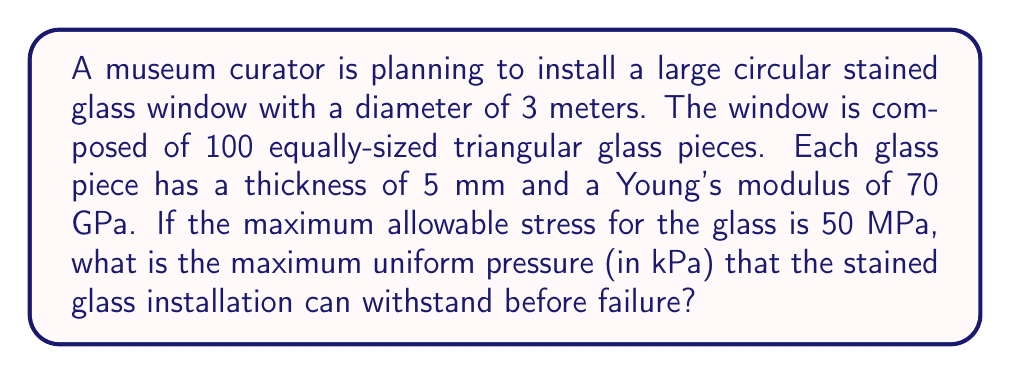Give your solution to this math problem. To solve this problem, we need to use stress analysis and the concept of structural integrity. Let's break it down step by step:

1. Calculate the area of the circular window:
   $$A = \pi r^2 = \pi (1.5\text{ m})^2 = 7.0686\text{ m}^2$$

2. Calculate the area of each triangular glass piece:
   $$A_{\text{piece}} = \frac{A}{100} = 0.070686\text{ m}^2$$

3. Assume each triangular piece is equilateral. Calculate the side length:
   $$s = \sqrt{\frac{4A_{\text{piece}}}{\sqrt{3}}} = 0.3162\text{ m}$$

4. Calculate the moment of inertia for a triangular cross-section:
   $$I = \frac{b h^3}{36} = \frac{0.3162 \cdot (0.005)^3}{36} = 3.655 \times 10^{-11}\text{ m}^4$$

5. Use the beam bending equation to relate stress to pressure:
   $$\sigma_{\text{max}} = \frac{M y}{I}$$
   where $M$ is the bending moment, $y$ is the distance from the neutral axis to the edge (half the thickness), and $I$ is the moment of inertia.

6. For a simply supported beam with uniform load:
   $$M = \frac{w L^2}{8}$$
   where $w$ is the distributed load (pressure times width) and $L$ is the length of the beam (side length of the triangle).

7. Combine these equations and solve for pressure $P$:
   $$50 \times 10^6 = \frac{(P \cdot 0.3162) \cdot (0.3162)^2}{8} \cdot \frac{0.005/2}{3.655 \times 10^{-11}}$$

8. Solve for $P$:
   $$P = \frac{50 \times 10^6 \cdot 8 \cdot 3.655 \times 10^{-11}}{0.3162^3 \cdot 0.0025} = 5834.8\text{ Pa}$$

9. Convert to kPa:
   $$P = 5.8348\text{ kPa}$$
Answer: The maximum uniform pressure that the stained glass installation can withstand before failure is approximately 5.83 kPa. 